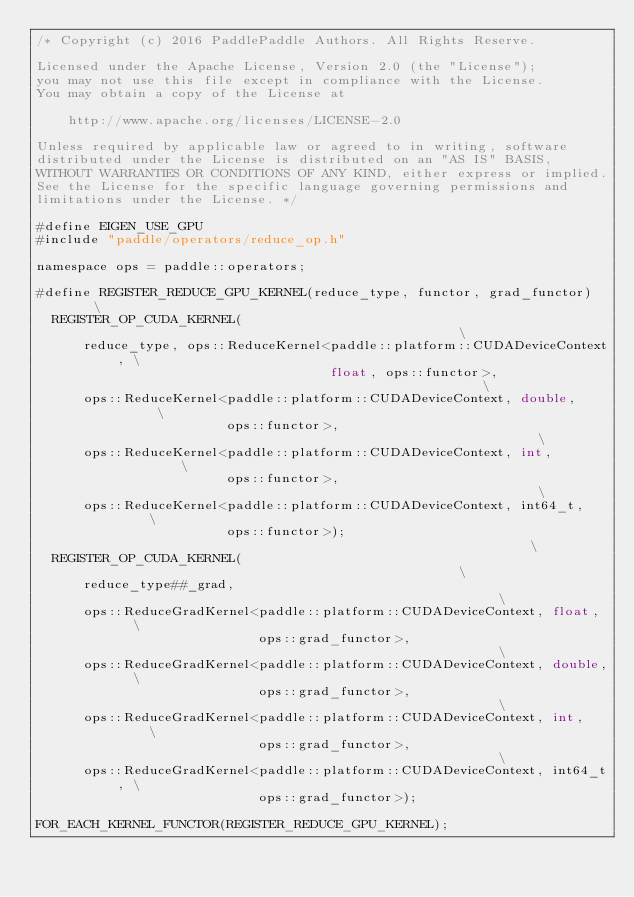Convert code to text. <code><loc_0><loc_0><loc_500><loc_500><_Cuda_>/* Copyright (c) 2016 PaddlePaddle Authors. All Rights Reserve.

Licensed under the Apache License, Version 2.0 (the "License");
you may not use this file except in compliance with the License.
You may obtain a copy of the License at

    http://www.apache.org/licenses/LICENSE-2.0

Unless required by applicable law or agreed to in writing, software
distributed under the License is distributed on an "AS IS" BASIS,
WITHOUT WARRANTIES OR CONDITIONS OF ANY KIND, either express or implied.
See the License for the specific language governing permissions and
limitations under the License. */

#define EIGEN_USE_GPU
#include "paddle/operators/reduce_op.h"

namespace ops = paddle::operators;

#define REGISTER_REDUCE_GPU_KERNEL(reduce_type, functor, grad_functor)    \
  REGISTER_OP_CUDA_KERNEL(                                                \
      reduce_type, ops::ReduceKernel<paddle::platform::CUDADeviceContext, \
                                     float, ops::functor>,                \
      ops::ReduceKernel<paddle::platform::CUDADeviceContext, double,      \
                        ops::functor>,                                    \
      ops::ReduceKernel<paddle::platform::CUDADeviceContext, int,         \
                        ops::functor>,                                    \
      ops::ReduceKernel<paddle::platform::CUDADeviceContext, int64_t,     \
                        ops::functor>);                                   \
  REGISTER_OP_CUDA_KERNEL(                                                \
      reduce_type##_grad,                                                 \
      ops::ReduceGradKernel<paddle::platform::CUDADeviceContext, float,   \
                            ops::grad_functor>,                           \
      ops::ReduceGradKernel<paddle::platform::CUDADeviceContext, double,  \
                            ops::grad_functor>,                           \
      ops::ReduceGradKernel<paddle::platform::CUDADeviceContext, int,     \
                            ops::grad_functor>,                           \
      ops::ReduceGradKernel<paddle::platform::CUDADeviceContext, int64_t, \
                            ops::grad_functor>);

FOR_EACH_KERNEL_FUNCTOR(REGISTER_REDUCE_GPU_KERNEL);
</code> 